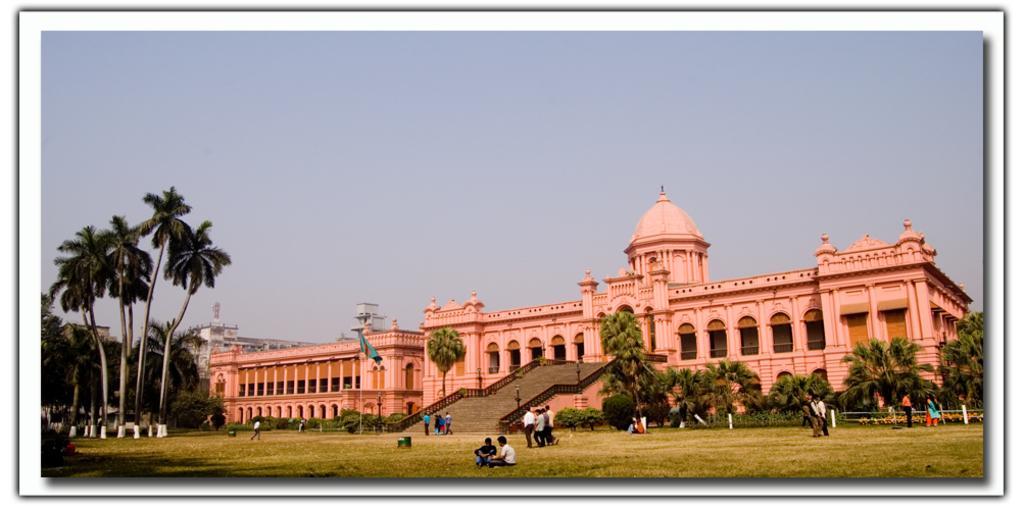Can you describe this image briefly? In this image we can see a photo. On the photo there is a building with pillars and arches. Also there are steps with railings. And there are many trees. And there is a flag with a pole. On the ground there is grass. And there are people. In the background there is sky. 